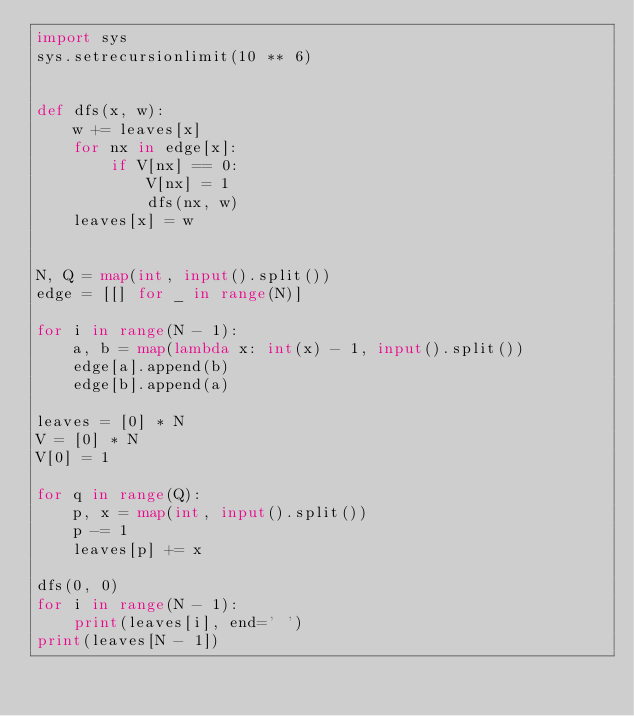<code> <loc_0><loc_0><loc_500><loc_500><_Python_>import sys
sys.setrecursionlimit(10 ** 6)


def dfs(x, w):
    w += leaves[x]
    for nx in edge[x]:
        if V[nx] == 0:
            V[nx] = 1
            dfs(nx, w)
    leaves[x] = w


N, Q = map(int, input().split())
edge = [[] for _ in range(N)]

for i in range(N - 1):
    a, b = map(lambda x: int(x) - 1, input().split())
    edge[a].append(b)
    edge[b].append(a)

leaves = [0] * N
V = [0] * N
V[0] = 1

for q in range(Q):
    p, x = map(int, input().split())
    p -= 1
    leaves[p] += x

dfs(0, 0)
for i in range(N - 1):
    print(leaves[i], end=' ')
print(leaves[N - 1])
</code> 